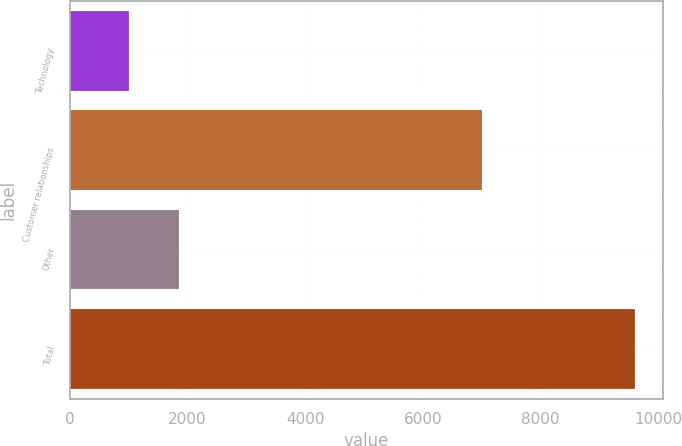<chart> <loc_0><loc_0><loc_500><loc_500><bar_chart><fcel>Technology<fcel>Customer relationships<fcel>Other<fcel>Total<nl><fcel>1000<fcel>7000<fcel>1860<fcel>9600<nl></chart> 